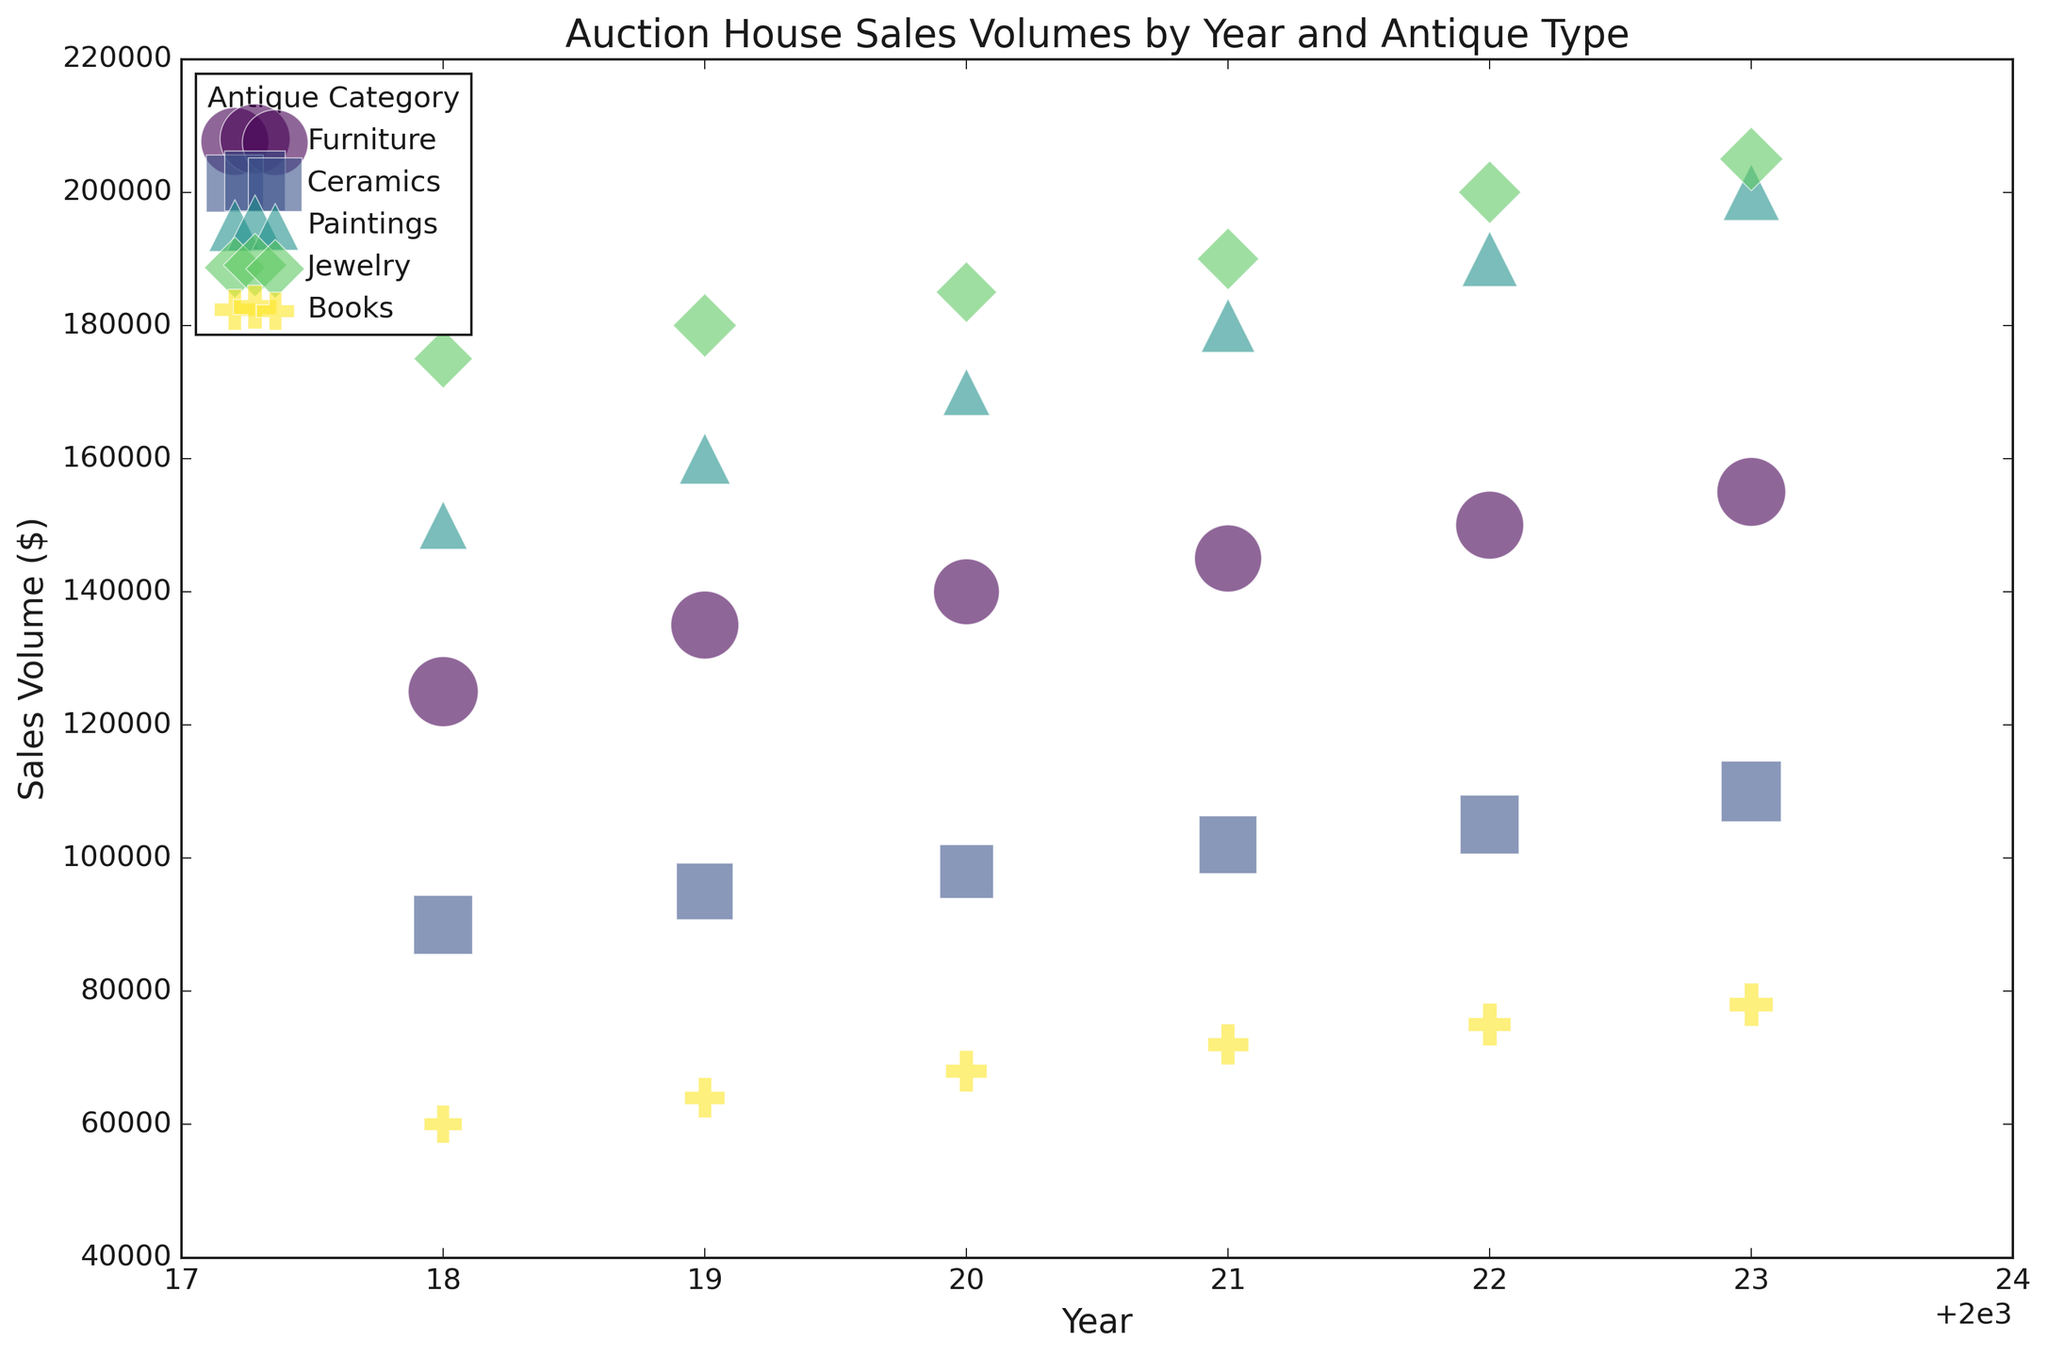Which category had the highest sales volume in 2020? By looking at the bubbles for 2020, we see that the Jewelry category has the highest vertical position, indicating the highest sales volume.
Answer: Jewelry How did the sales volume of Furniture change from 2018 to 2023? The figure shows that in 2018, the sales volume of Furniture was $125,000, and by 2023, it increased to $155,000. The change is $155,000 - $125,000 = $30,000.
Answer: Increased by $30,000 Which year had the highest number of sales in the Ceramics category? By comparing the sizes of the bubbles for Ceramics across the years, 2023 has the largest bubble, indicating the highest number of sales.
Answer: 2023 Compare the sales volumes of Paintings and Jewelry in 2021. Which is higher and by how much? In 2021, the sales volume of Paintings is $180,000, and Jewelry is $190,000. Jewelry has a higher sales volume, with a difference of $190,000 - $180,000 = $10,000.
Answer: Jewelry by $10,000 What is the visual trend in the sales volume of Books from 2018 to 2023? Observing the vertical positions of the bubbles for Books across the years, there is a gradual upward trend from $60,000 in 2018 to $78,000 in 2023.
Answer: Gradual increase In which year did Furniture have its smallest bubble size and what might this indicate? The smallest bubble for Furniture appears in 2018. Smaller bubbles indicate fewer number of sales, so this suggests that 2018 had the lowest number of sales for Furniture.
Answer: 2018, fewer sales Which category showed the most consistent increase in sales volume over the years? By observing the trend lines for each category, Jewelry shows a consistent increase in sales volume from 2018 to 2023 without any dips.
Answer: Jewelry What is the general relationship between the bubble size and the sales volume across all categories? Generally, larger bubbles tend to align with higher sales volumes, indicating that higher sales volumes often correspond with a larger number of sales.
Answer: Larger bubbles, higher sales How do the sales volumes of Ceramics and Books in 2022 compare? In 2022, the sales volume of Ceramics is $105,000, while Books has $75,000. Ceramics has a higher sales volume by $105,000 - $75,000 = $30,000.
Answer: Ceramics by $30,000 